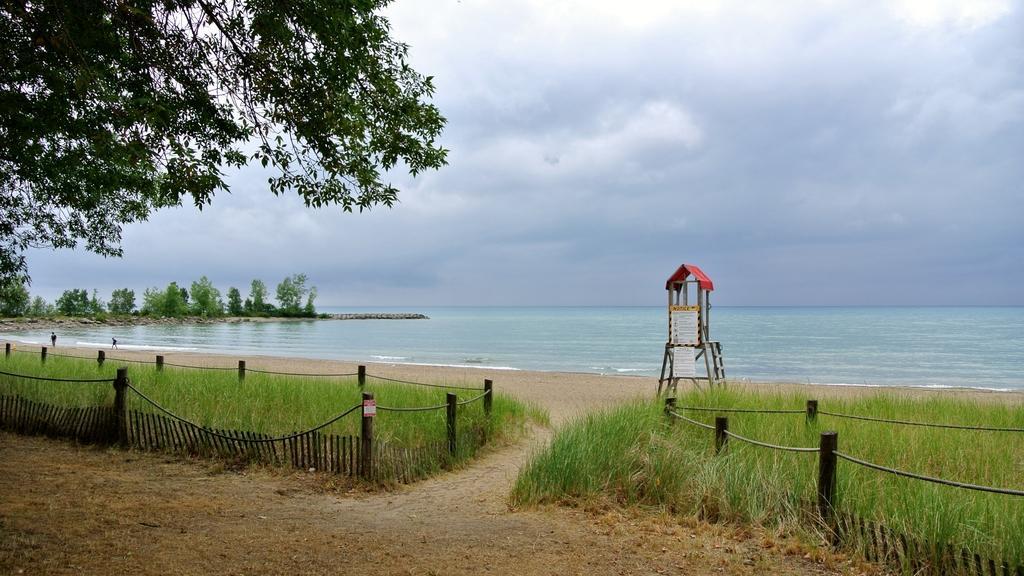How would you summarize this image in a sentence or two? In this image we can see some grass, a wooden fence, some poles tied with ropes, a lifeguard stand, some boards with text on them, a large water body, a group of trees and the sky which looks cloudy. 